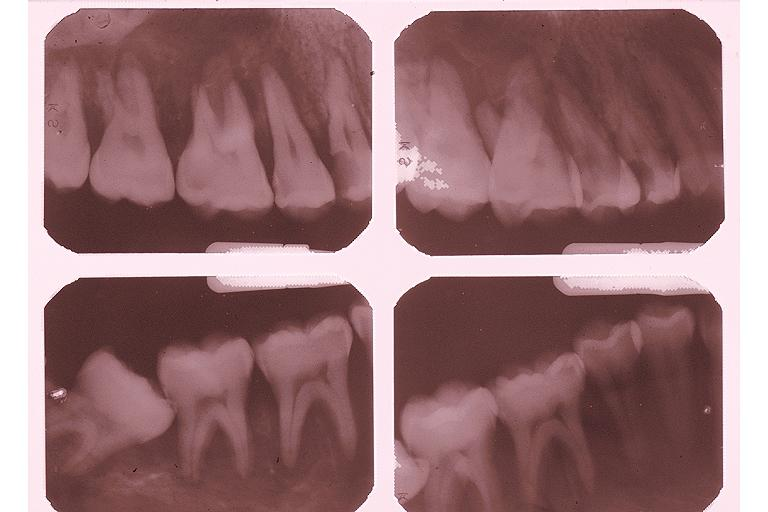s good example of muscle atrophy present?
Answer the question using a single word or phrase. No 